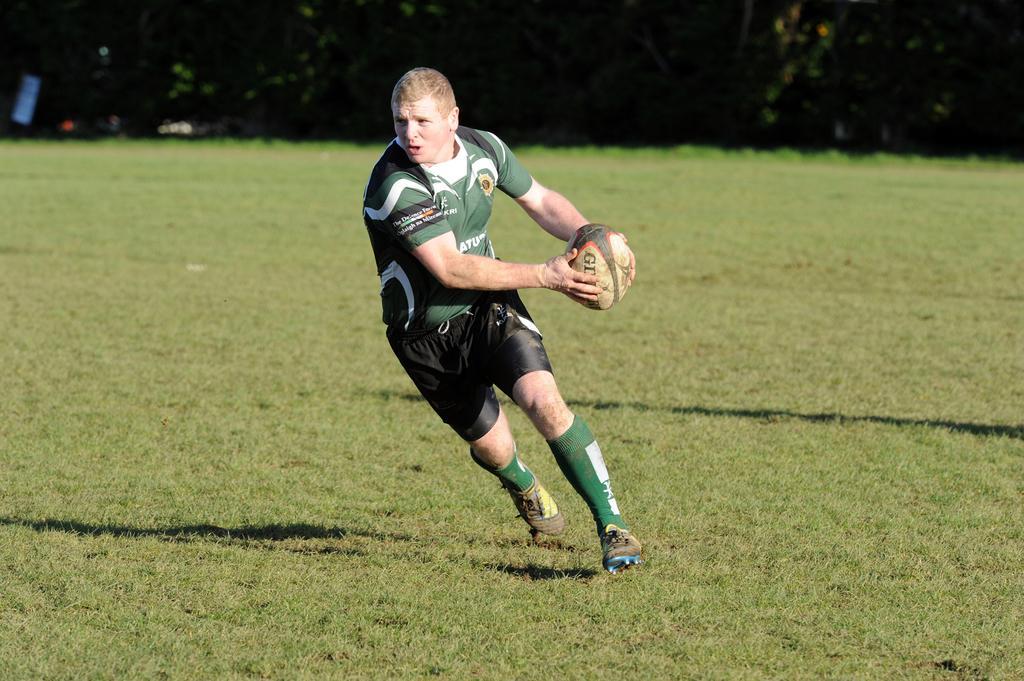How would you summarize this image in a sentence or two? This person running and holding ball. This is grass. We can see trees. 